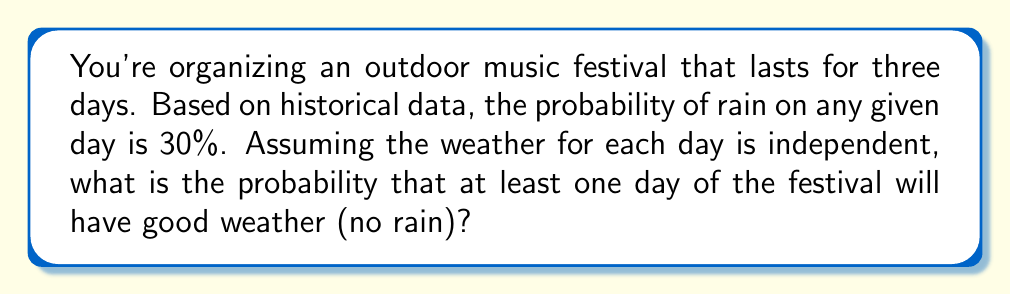Help me with this question. Let's approach this step-by-step:

1) First, let's consider the probability of rain for each day:
   $P(\text{rain}) = 0.30$ or 30%

2) The probability of good weather (no rain) for one day is:
   $P(\text{good weather}) = 1 - P(\text{rain}) = 1 - 0.30 = 0.70$ or 70%

3) We want at least one day of good weather. It's easier to calculate the probability of all three days having rain and then subtract that from 1.

4) The probability of all three days having rain:
   $P(\text{all rainy}) = 0.30 \times 0.30 \times 0.30 = 0.30^3 = 0.027$ or 2.7%

5) Therefore, the probability of at least one day having good weather is:
   $P(\text{at least one good}) = 1 - P(\text{all rainy})$
   $= 1 - 0.027 = 0.973$ or 97.3%

6) We can verify this using the complement rule:
   $P(\text{at least one good}) = 1 - (1 - 0.70)^3 = 1 - 0.30^3 = 0.973$

Thus, there's a 97.3% chance that at least one day of the festival will have good weather.
Answer: 0.973 or 97.3% 